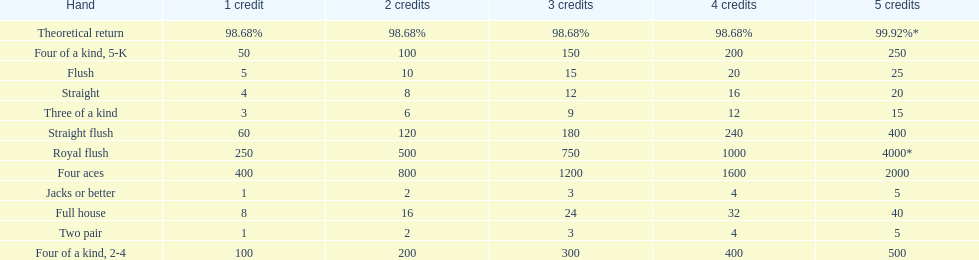Which is a higher standing hand: a straight or a flush? Flush. 